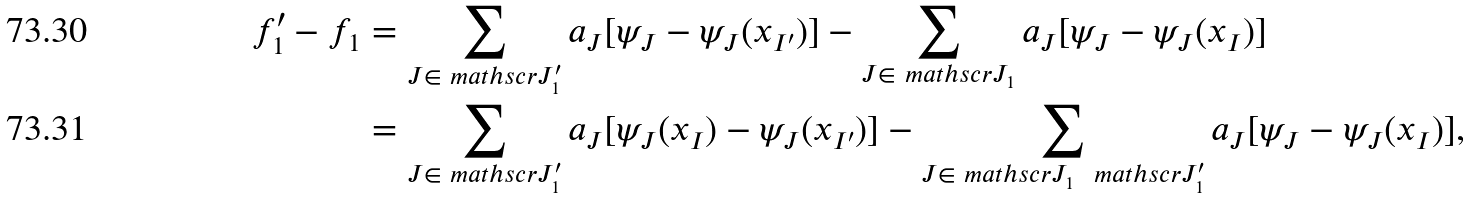<formula> <loc_0><loc_0><loc_500><loc_500>f _ { 1 } ^ { \prime } - f _ { 1 } & = \sum _ { J \in \ m a t h s c r { J } _ { 1 } ^ { \prime } } a _ { J } [ \psi _ { J } - \psi _ { J } ( x _ { I ^ { \prime } } ) ] - \sum _ { J \in \ m a t h s c r { J } _ { 1 } } a _ { J } [ \psi _ { J } - \psi _ { J } ( x _ { I } ) ] \\ & = \sum _ { J \in \ m a t h s c r { J } _ { 1 } ^ { \prime } } a _ { J } [ \psi _ { J } ( x _ { I } ) - \psi _ { J } ( x _ { I ^ { \prime } } ) ] - \sum _ { J \in \ m a t h s c r { J } _ { 1 } \ \ m a t h s c r { J } _ { 1 } ^ { \prime } } a _ { J } [ \psi _ { J } - \psi _ { J } ( x _ { I } ) ] ,</formula> 